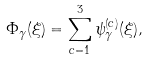<formula> <loc_0><loc_0><loc_500><loc_500>\Phi _ { \gamma } ( \xi ) = \sum _ { c = 1 } ^ { 3 } \psi ^ { ( c ) } _ { \gamma } ( \xi ) ,</formula> 